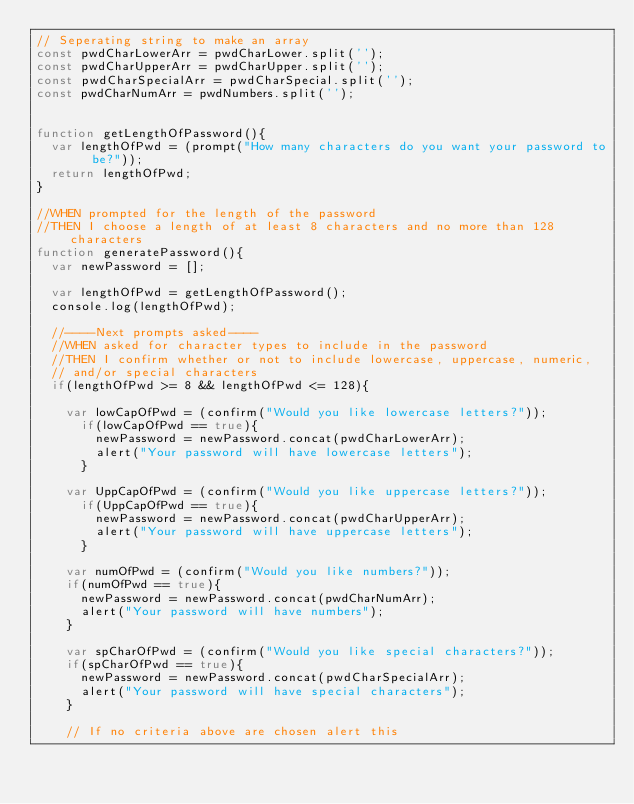Convert code to text. <code><loc_0><loc_0><loc_500><loc_500><_JavaScript_>// Seperating string to make an array 
const pwdCharLowerArr = pwdCharLower.split('');
const pwdCharUpperArr = pwdCharUpper.split('');
const pwdCharSpecialArr = pwdCharSpecial.split('');
const pwdCharNumArr = pwdNumbers.split('');


function getLengthOfPassword(){
  var lengthOfPwd = (prompt("How many characters do you want your password to be?"));
  return lengthOfPwd;
}

//WHEN prompted for the length of the password                  
//THEN I choose a length of at least 8 characters and no more than 128 characters 
function generatePassword(){
  var newPassword = [];

  var lengthOfPwd = getLengthOfPassword();
  console.log(lengthOfPwd);
  
  //----Next prompts asked----
  //WHEN asked for character types to include in the password
  //THEN I confirm whether or not to include lowercase, uppercase, numeric, 
  // and/or special characters
  if(lengthOfPwd >= 8 && lengthOfPwd <= 128){

    var lowCapOfPwd = (confirm("Would you like lowercase letters?"));
      if(lowCapOfPwd == true){
        newPassword = newPassword.concat(pwdCharLowerArr);
        alert("Your password will have lowercase letters");
      } 

    var UppCapOfPwd = (confirm("Would you like uppercase letters?"));
      if(UppCapOfPwd == true){
        newPassword = newPassword.concat(pwdCharUpperArr);
        alert("Your password will have uppercase letters");
      } 

    var numOfPwd = (confirm("Would you like numbers?"));
    if(numOfPwd == true){
      newPassword = newPassword.concat(pwdCharNumArr);
      alert("Your password will have numbers");
    } 
    
    var spCharOfPwd = (confirm("Would you like special characters?"));
    if(spCharOfPwd == true){
      newPassword = newPassword.concat(pwdCharSpecialArr);
      alert("Your password will have special characters");
    } 

    // If no criteria above are chosen alert this</code> 